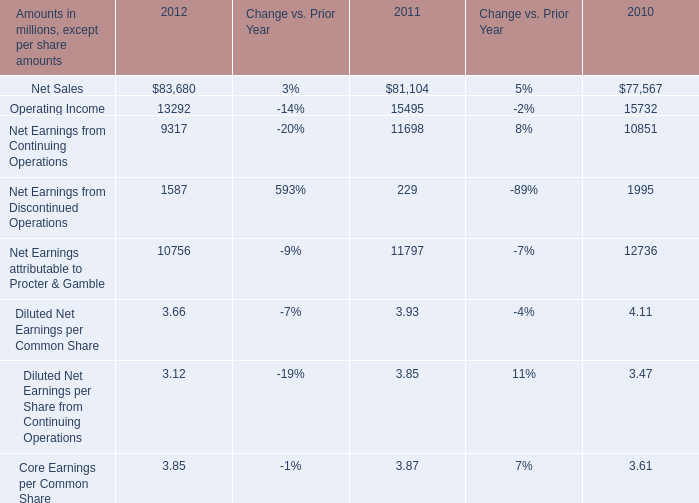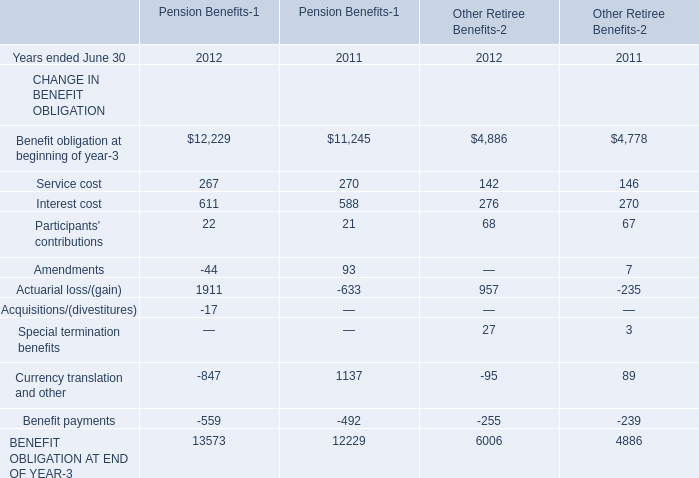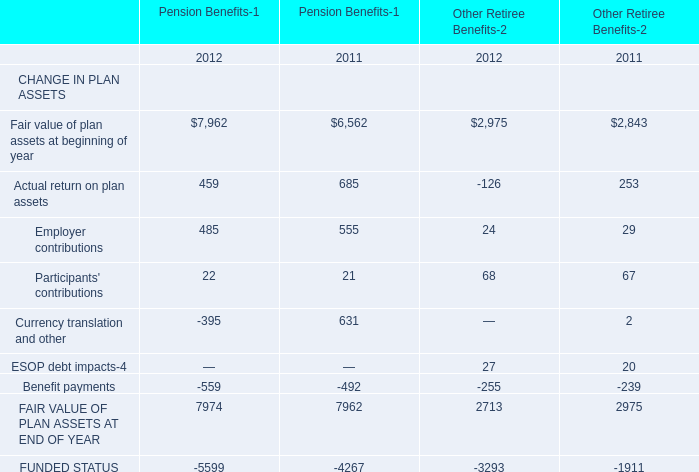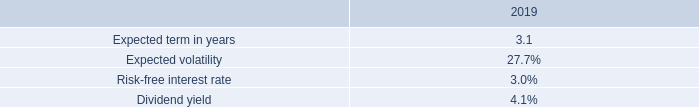what was the value of the restricted stock units awarded in the mps acquisition? ( $ ) 
Computations: (119373 * 54.24)
Answer: 6474791.52. 